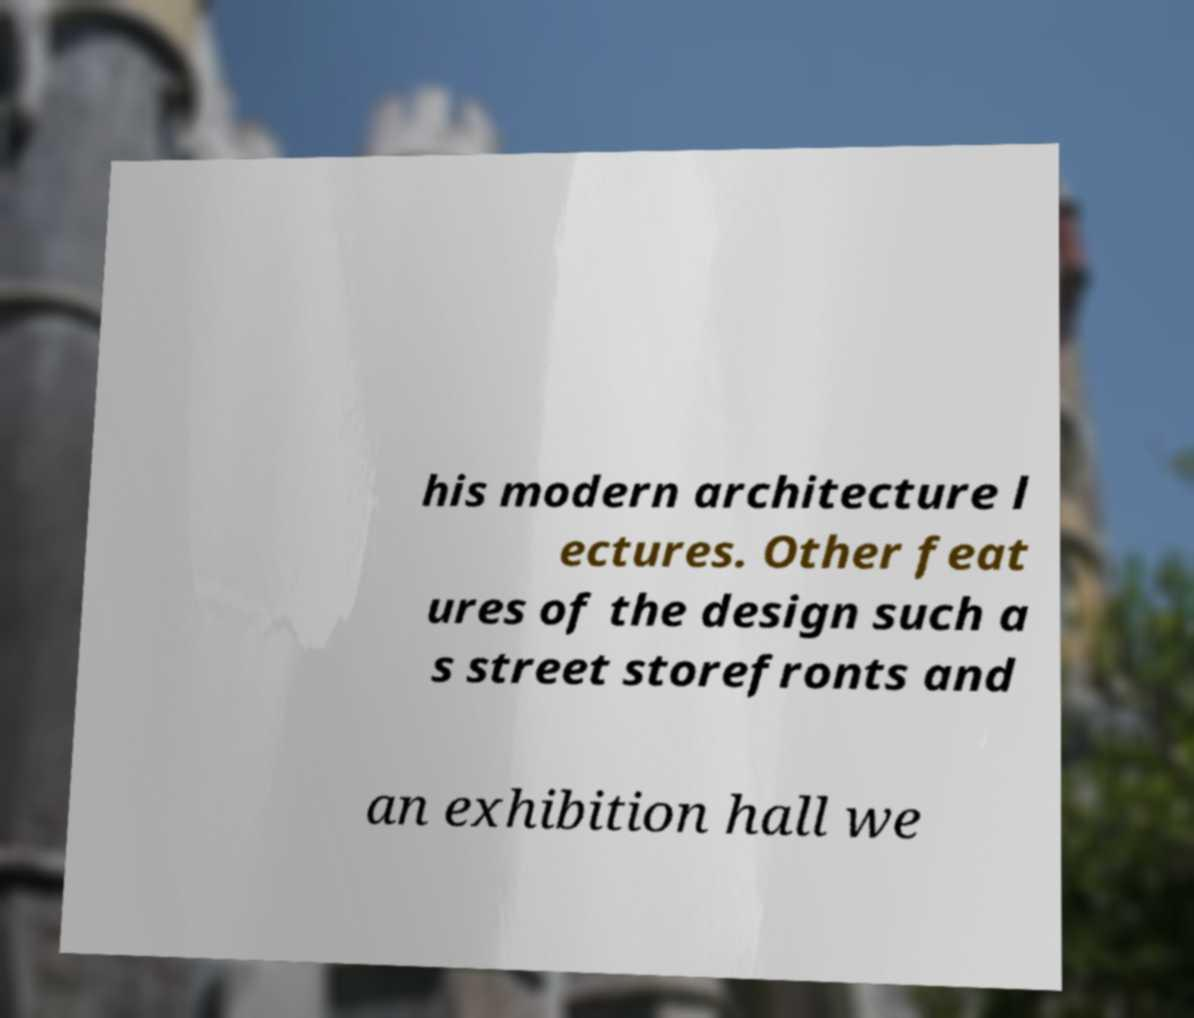For documentation purposes, I need the text within this image transcribed. Could you provide that? his modern architecture l ectures. Other feat ures of the design such a s street storefronts and an exhibition hall we 